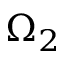Convert formula to latex. <formula><loc_0><loc_0><loc_500><loc_500>\Omega _ { 2 }</formula> 